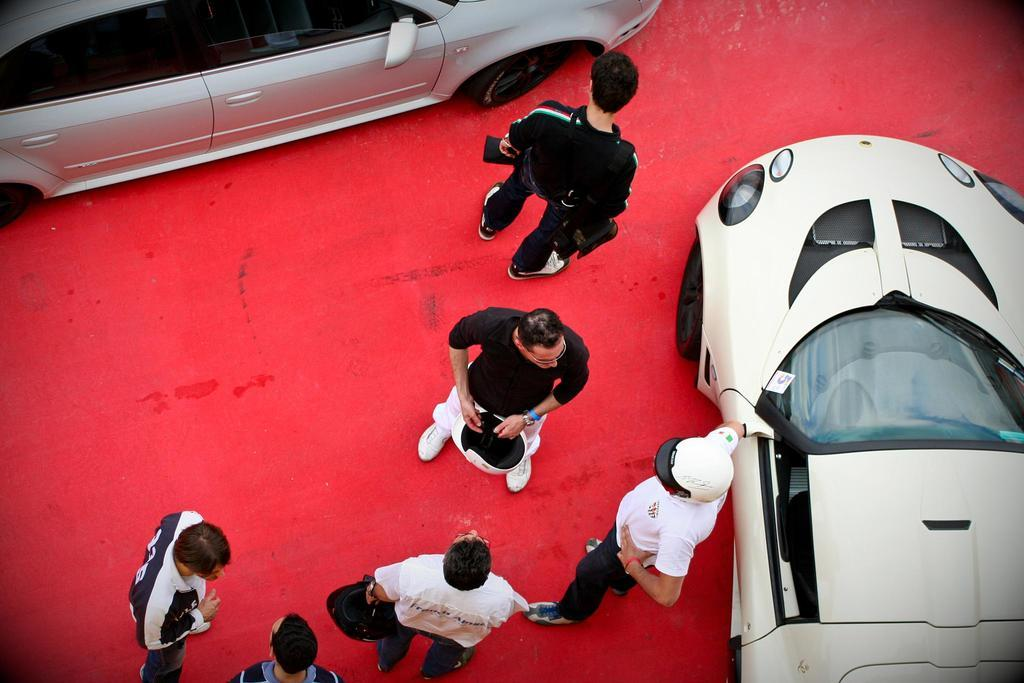What is the main subject of the image? The main subject of the image is a group of people. What is the people standing on in the image? The people are standing on a red color carpet. What else can be seen in the image besides the group of people? Cars are visible beside the group of people. What type of brass instrument is being played by the group of people in the image? There is no brass instrument being played by the group of people in the image. Can you provide an example of a brass instrument that might be played in a similar setting? In a similar setting, a brass instrument like a trumpet or trombone might be played, but there is no such instrument present in the image. 